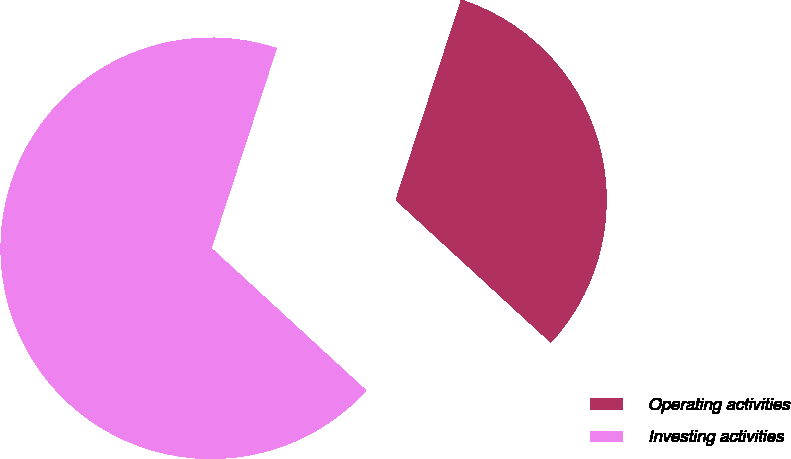<chart> <loc_0><loc_0><loc_500><loc_500><pie_chart><fcel>Operating activities<fcel>Investing activities<nl><fcel>31.81%<fcel>68.19%<nl></chart> 